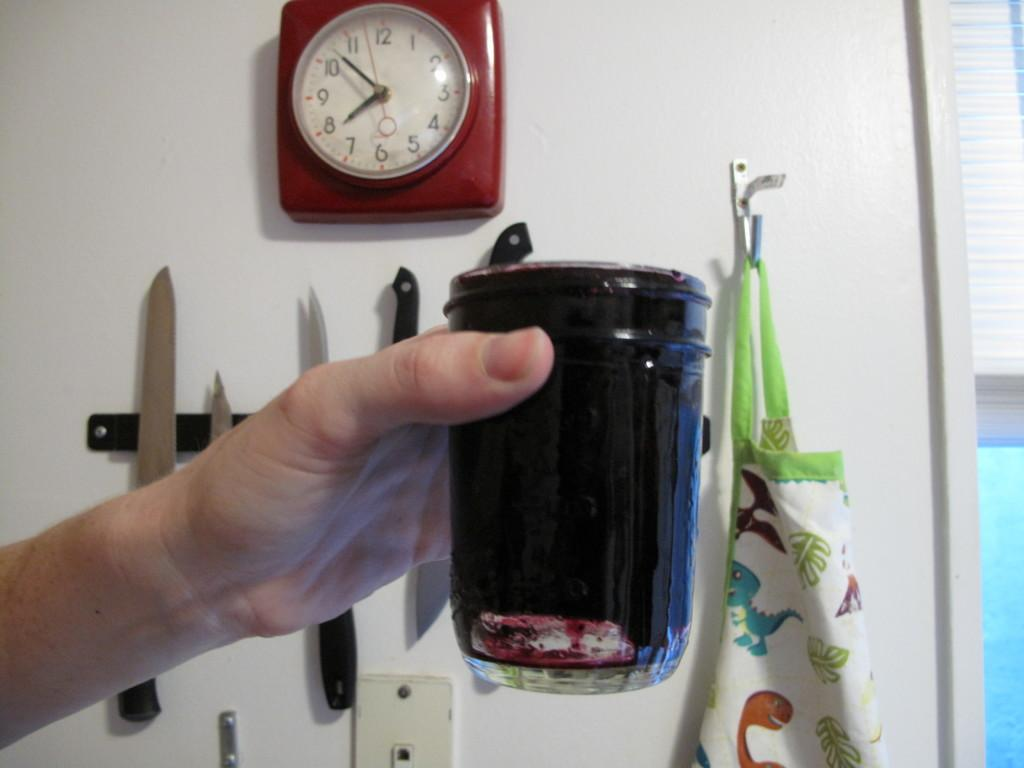Provide a one-sentence caption for the provided image. A hand holding up a glass full of a dark liquid with a clock that reads 8:53 on its face. 